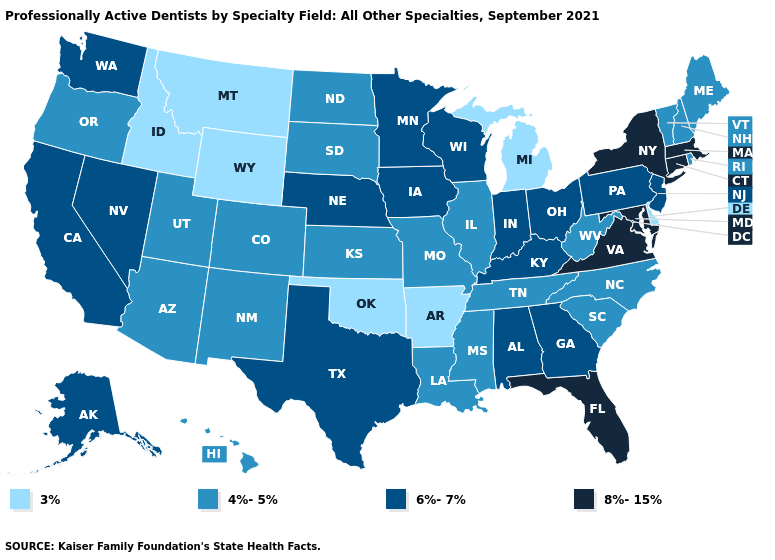Which states hav the highest value in the MidWest?
Concise answer only. Indiana, Iowa, Minnesota, Nebraska, Ohio, Wisconsin. What is the value of Pennsylvania?
Keep it brief. 6%-7%. Which states have the lowest value in the USA?
Concise answer only. Arkansas, Delaware, Idaho, Michigan, Montana, Oklahoma, Wyoming. How many symbols are there in the legend?
Answer briefly. 4. Name the states that have a value in the range 4%-5%?
Answer briefly. Arizona, Colorado, Hawaii, Illinois, Kansas, Louisiana, Maine, Mississippi, Missouri, New Hampshire, New Mexico, North Carolina, North Dakota, Oregon, Rhode Island, South Carolina, South Dakota, Tennessee, Utah, Vermont, West Virginia. What is the value of Arizona?
Keep it brief. 4%-5%. Does New Mexico have the lowest value in the USA?
Concise answer only. No. Does Ohio have the same value as Utah?
Keep it brief. No. Does South Dakota have the lowest value in the USA?
Give a very brief answer. No. What is the value of South Dakota?
Write a very short answer. 4%-5%. Does Virginia have the lowest value in the South?
Write a very short answer. No. What is the lowest value in states that border Mississippi?
Be succinct. 3%. Does the map have missing data?
Quick response, please. No. Does Louisiana have the lowest value in the USA?
Answer briefly. No. 